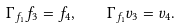<formula> <loc_0><loc_0><loc_500><loc_500>\Gamma _ { f _ { 1 } } f _ { 3 } = f _ { 4 } , \quad \Gamma _ { f _ { 1 } } v _ { 3 } = v _ { 4 } .</formula> 